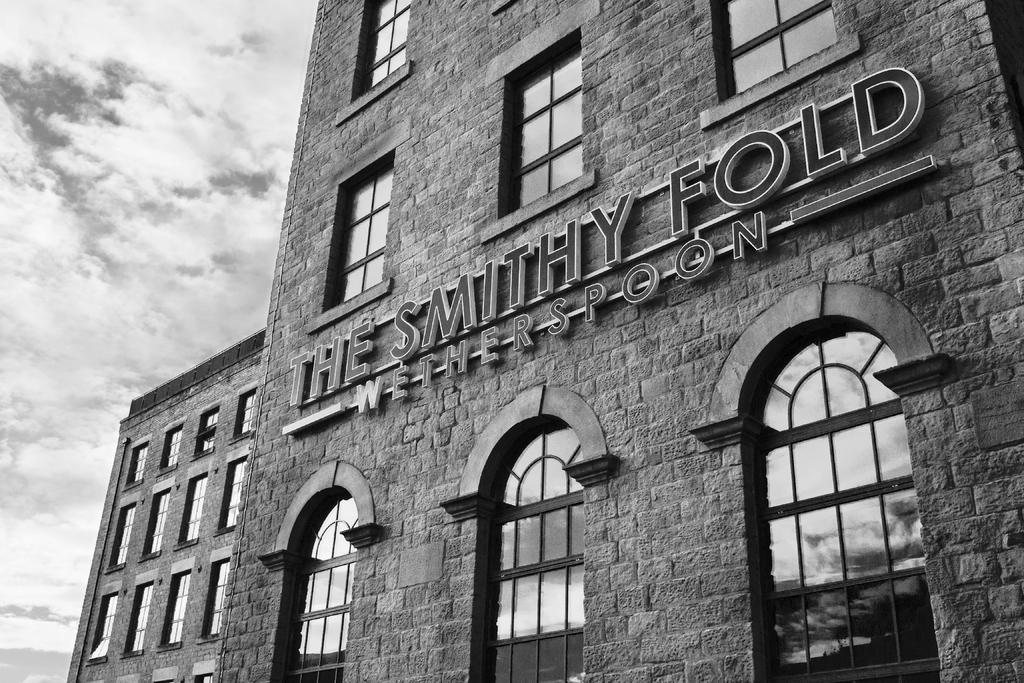What is the color scheme of the image? The image is black and white. What is the main subject in the image? There is a building in the image. What specific features can be observed on the building? The building has windows, and there is text or writing on the building. What can be seen in the background of the image? The sky is visible in the background of the image. What is the condition of the sky in the image? There are clouds in the sky. What type of wool is being used to create the hammer in the image? There is no wool or hammer present in the image. Who gave their approval for the building in the image? The image does not provide information about who gave approval for the building. 